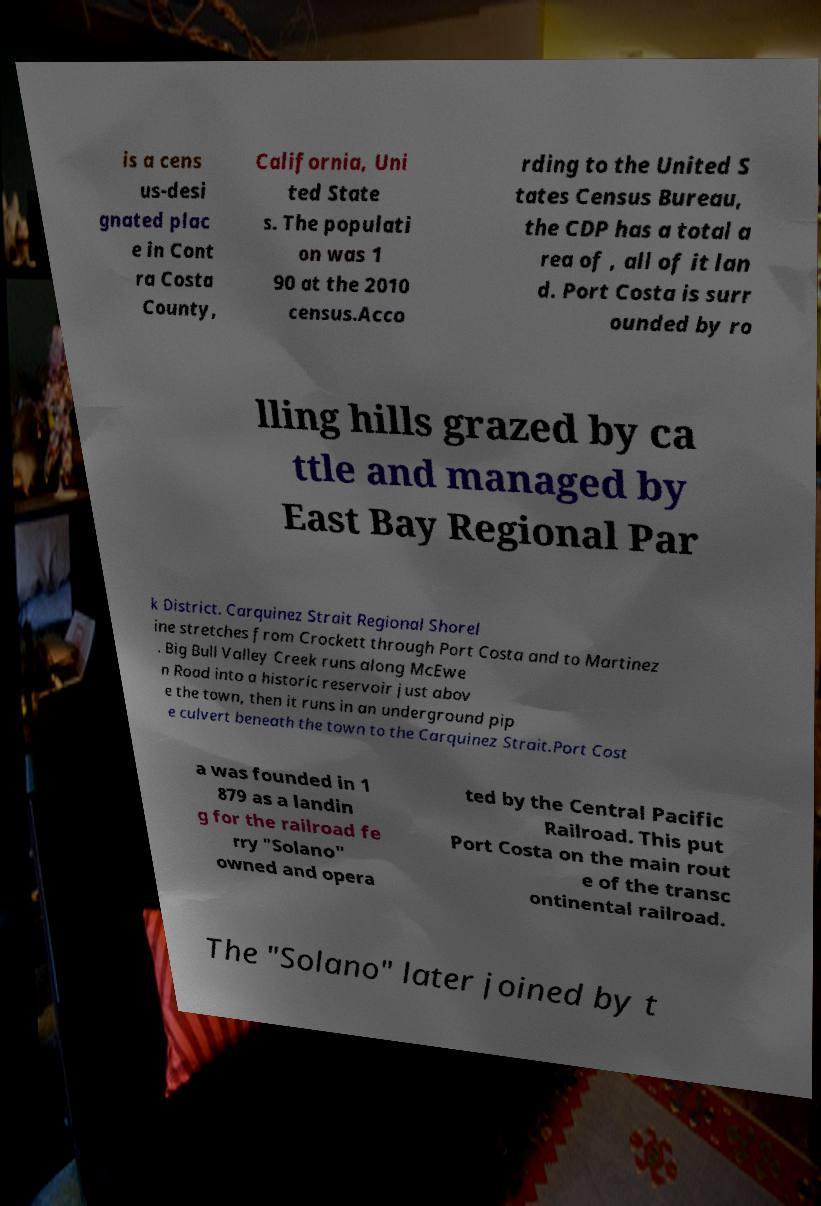Could you extract and type out the text from this image? is a cens us-desi gnated plac e in Cont ra Costa County, California, Uni ted State s. The populati on was 1 90 at the 2010 census.Acco rding to the United S tates Census Bureau, the CDP has a total a rea of , all of it lan d. Port Costa is surr ounded by ro lling hills grazed by ca ttle and managed by East Bay Regional Par k District. Carquinez Strait Regional Shorel ine stretches from Crockett through Port Costa and to Martinez . Big Bull Valley Creek runs along McEwe n Road into a historic reservoir just abov e the town, then it runs in an underground pip e culvert beneath the town to the Carquinez Strait.Port Cost a was founded in 1 879 as a landin g for the railroad fe rry "Solano" owned and opera ted by the Central Pacific Railroad. This put Port Costa on the main rout e of the transc ontinental railroad. The "Solano" later joined by t 